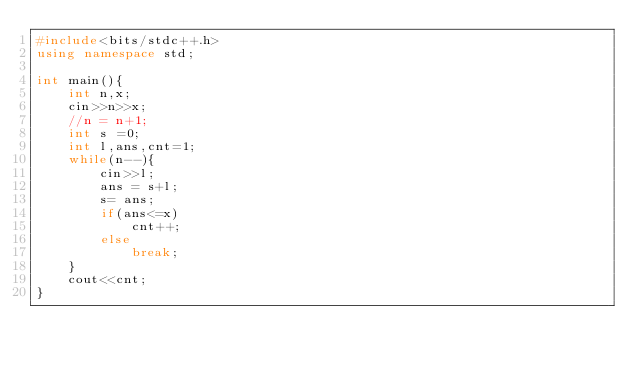<code> <loc_0><loc_0><loc_500><loc_500><_C++_>#include<bits/stdc++.h>
using namespace std;

int main(){
	int n,x;
	cin>>n>>x;
	//n = n+1;
	int s =0;
	int l,ans,cnt=1;
	while(n--){
		cin>>l;
		ans = s+l;
		s= ans;
		if(ans<=x)
			cnt++;
		else
			break;
	}
	cout<<cnt;
}</code> 